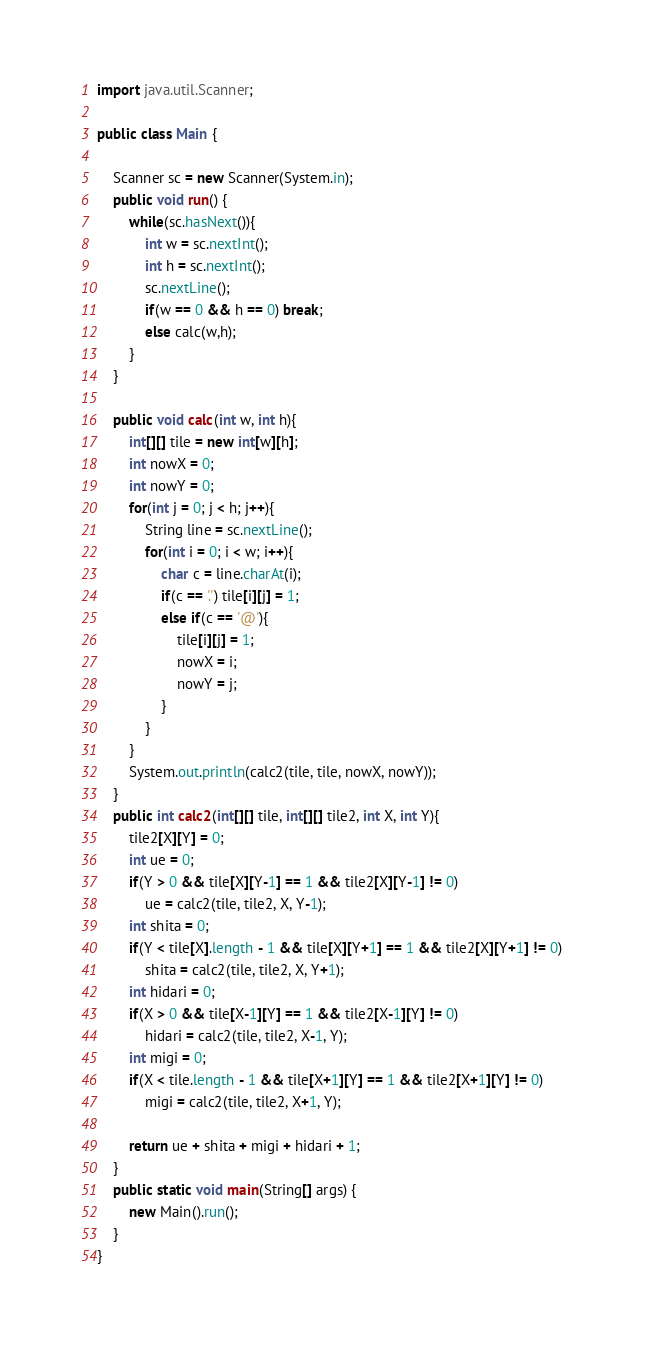<code> <loc_0><loc_0><loc_500><loc_500><_Java_>import java.util.Scanner;

public class Main {
	
	Scanner sc = new Scanner(System.in);
	public void run() {
		while(sc.hasNext()){
			int w = sc.nextInt();
			int h = sc.nextInt();
			sc.nextLine();
			if(w == 0 && h == 0) break;
			else calc(w,h);
		}
	}

	public void calc(int w, int h){
		int[][] tile = new int[w][h];
		int nowX = 0;
		int nowY = 0;
		for(int j = 0; j < h; j++){
			String line = sc.nextLine();
			for(int i = 0; i < w; i++){
				char c = line.charAt(i);
				if(c == '.') tile[i][j] = 1;
				else if(c == '@'){
					tile[i][j] = 1;
					nowX = i;
					nowY = j;
				}
			}
		}
		System.out.println(calc2(tile, tile, nowX, nowY));
	}
	public int calc2(int[][] tile, int[][] tile2, int X, int Y){
		tile2[X][Y] = 0;
 		int ue = 0;
		if(Y > 0 && tile[X][Y-1] == 1 && tile2[X][Y-1] != 0) 
			ue = calc2(tile, tile2, X, Y-1);
		int shita = 0;
		if(Y < tile[X].length - 1 && tile[X][Y+1] == 1 && tile2[X][Y+1] != 0) 
			shita = calc2(tile, tile2, X, Y+1);
		int hidari = 0;
		if(X > 0 && tile[X-1][Y] == 1 && tile2[X-1][Y] != 0)
			hidari = calc2(tile, tile2, X-1, Y);
		int migi = 0;
		if(X < tile.length - 1 && tile[X+1][Y] == 1 && tile2[X+1][Y] != 0)
			migi = calc2(tile, tile2, X+1, Y);
		
		return ue + shita + migi + hidari + 1;
	}
	public static void main(String[] args) {
		new Main().run();
	}
}</code> 